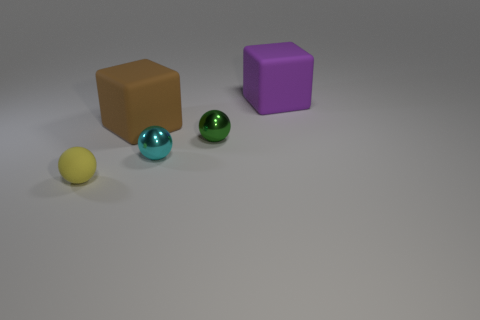Are there any other things that are made of the same material as the brown cube?
Make the answer very short. Yes. What number of big things are green metallic things or cyan balls?
Keep it short and to the point. 0. Is the shape of the matte object behind the large brown block the same as  the small yellow rubber object?
Ensure brevity in your answer.  No. Are there fewer tiny cyan objects than small gray cylinders?
Your answer should be very brief. No. Is there anything else that has the same color as the tiny rubber thing?
Give a very brief answer. No. There is a shiny thing that is in front of the tiny green shiny ball; what shape is it?
Provide a short and direct response. Sphere. There is a small matte object; is its color the same as the large matte cube to the left of the small cyan sphere?
Your answer should be compact. No. Is the number of green shiny objects that are right of the brown thing the same as the number of tiny matte balls that are to the left of the cyan metal object?
Your response must be concise. Yes. What number of other things are the same size as the brown matte thing?
Give a very brief answer. 1. How big is the brown cube?
Your response must be concise. Large. 